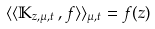Convert formula to latex. <formula><loc_0><loc_0><loc_500><loc_500>\langle \langle \mathbb { K } _ { z , \mu , t } \, , f \rangle \rangle _ { \mu , t } = f ( z )</formula> 